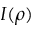<formula> <loc_0><loc_0><loc_500><loc_500>I ( \rho )</formula> 